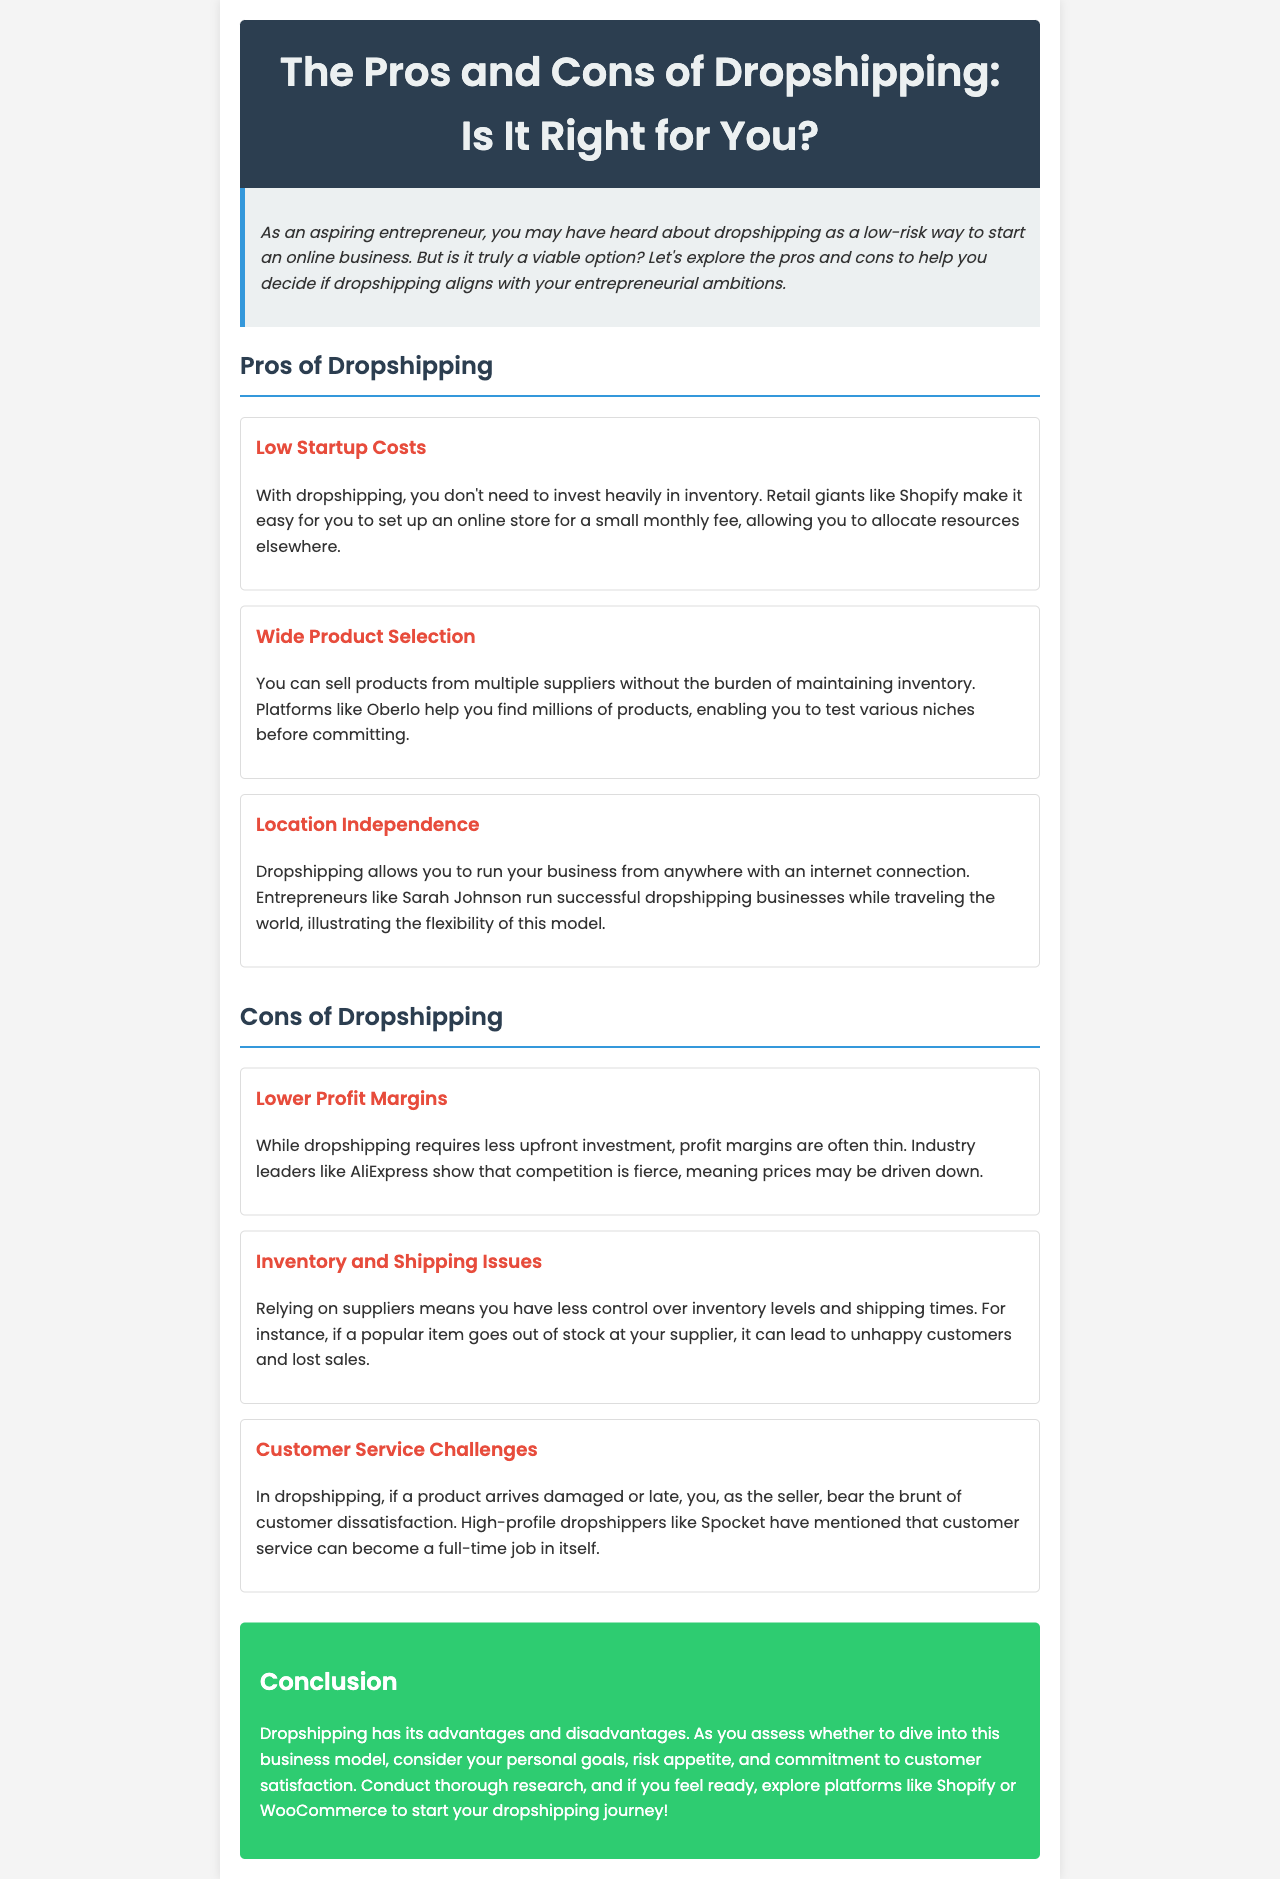What is the title of the newsletter? The title is provided in the header section of the document, which is "The Pros and Cons of Dropshipping: Is It Right for You?".
Answer: The Pros and Cons of Dropshipping: Is It Right for You? What is one platform mentioned for setting up an online store? The document lists Shopify as an example of a platform for setting up an online store.
Answer: Shopify What is a challenge mentioned regarding customer service in dropshipping? The document outlines that customer dissatisfaction often falls on the seller when issues occur, making it a challenge.
Answer: Customer dissatisfaction How does dropshipping affect location for an entrepreneur? The document states that dropshipping allows for location independence, meaning business owners can operate from anywhere with internet access.
Answer: Location independence What is a pro of dropshipping related to startup costs? The newsletter highlights that one of the advantages of dropshipping is low startup costs due to minimal inventory investment.
Answer: Low startup costs What is a specific inventory issue mentioned in the document? The document indicates that relying on suppliers can lead to inventory issues, such as popular items going out of stock.
Answer: Popular items out of stock How does the document describe profit margins in dropshipping? The content specifies that profit margins in dropshipping are often thin due to competitive pricing pressures.
Answer: Thin What type of documentation is this text representing? The text is framed as a newsletter intended for aspiring entrepreneurs contemplating dropshipping.
Answer: Newsletter 